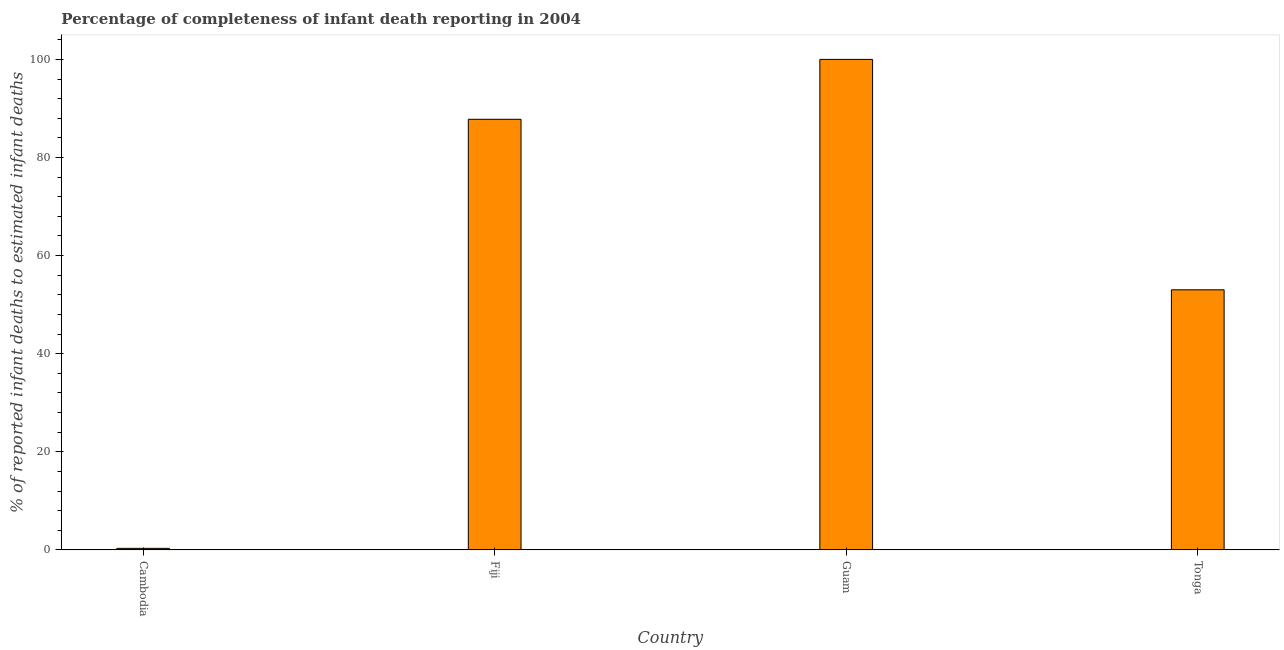Does the graph contain any zero values?
Offer a very short reply. No. Does the graph contain grids?
Provide a short and direct response. No. What is the title of the graph?
Ensure brevity in your answer.  Percentage of completeness of infant death reporting in 2004. What is the label or title of the X-axis?
Provide a succinct answer. Country. What is the label or title of the Y-axis?
Give a very brief answer. % of reported infant deaths to estimated infant deaths. What is the completeness of infant death reporting in Fiji?
Give a very brief answer. 87.79. Across all countries, what is the minimum completeness of infant death reporting?
Your response must be concise. 0.32. In which country was the completeness of infant death reporting maximum?
Make the answer very short. Guam. In which country was the completeness of infant death reporting minimum?
Your answer should be very brief. Cambodia. What is the sum of the completeness of infant death reporting?
Make the answer very short. 241.14. What is the difference between the completeness of infant death reporting in Guam and Tonga?
Your response must be concise. 46.97. What is the average completeness of infant death reporting per country?
Your response must be concise. 60.28. What is the median completeness of infant death reporting?
Offer a terse response. 70.41. What is the ratio of the completeness of infant death reporting in Cambodia to that in Fiji?
Your response must be concise. 0. Is the completeness of infant death reporting in Cambodia less than that in Fiji?
Provide a succinct answer. Yes. Is the difference between the completeness of infant death reporting in Fiji and Guam greater than the difference between any two countries?
Your answer should be very brief. No. What is the difference between the highest and the second highest completeness of infant death reporting?
Keep it short and to the point. 12.21. Is the sum of the completeness of infant death reporting in Fiji and Tonga greater than the maximum completeness of infant death reporting across all countries?
Your answer should be compact. Yes. What is the difference between the highest and the lowest completeness of infant death reporting?
Provide a short and direct response. 99.68. What is the difference between two consecutive major ticks on the Y-axis?
Your answer should be compact. 20. Are the values on the major ticks of Y-axis written in scientific E-notation?
Your answer should be very brief. No. What is the % of reported infant deaths to estimated infant deaths in Cambodia?
Offer a terse response. 0.32. What is the % of reported infant deaths to estimated infant deaths of Fiji?
Offer a terse response. 87.79. What is the % of reported infant deaths to estimated infant deaths in Guam?
Provide a succinct answer. 100. What is the % of reported infant deaths to estimated infant deaths in Tonga?
Provide a short and direct response. 53.03. What is the difference between the % of reported infant deaths to estimated infant deaths in Cambodia and Fiji?
Provide a short and direct response. -87.47. What is the difference between the % of reported infant deaths to estimated infant deaths in Cambodia and Guam?
Provide a succinct answer. -99.68. What is the difference between the % of reported infant deaths to estimated infant deaths in Cambodia and Tonga?
Keep it short and to the point. -52.71. What is the difference between the % of reported infant deaths to estimated infant deaths in Fiji and Guam?
Your answer should be compact. -12.21. What is the difference between the % of reported infant deaths to estimated infant deaths in Fiji and Tonga?
Your answer should be very brief. 34.76. What is the difference between the % of reported infant deaths to estimated infant deaths in Guam and Tonga?
Your response must be concise. 46.97. What is the ratio of the % of reported infant deaths to estimated infant deaths in Cambodia to that in Fiji?
Ensure brevity in your answer.  0. What is the ratio of the % of reported infant deaths to estimated infant deaths in Cambodia to that in Guam?
Your answer should be compact. 0. What is the ratio of the % of reported infant deaths to estimated infant deaths in Cambodia to that in Tonga?
Provide a short and direct response. 0.01. What is the ratio of the % of reported infant deaths to estimated infant deaths in Fiji to that in Guam?
Your response must be concise. 0.88. What is the ratio of the % of reported infant deaths to estimated infant deaths in Fiji to that in Tonga?
Your answer should be compact. 1.66. What is the ratio of the % of reported infant deaths to estimated infant deaths in Guam to that in Tonga?
Your response must be concise. 1.89. 